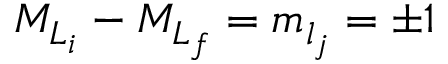<formula> <loc_0><loc_0><loc_500><loc_500>{ M } _ { { L } _ { i } } - { M } _ { { L } _ { f } } = { m } _ { l _ { j } } = \pm 1</formula> 